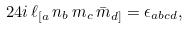Convert formula to latex. <formula><loc_0><loc_0><loc_500><loc_500>2 4 i \, \ell _ { [ a } \, n _ { b } \, m _ { c } \, \bar { m } _ { d ] } = \epsilon _ { a b c d } ,</formula> 